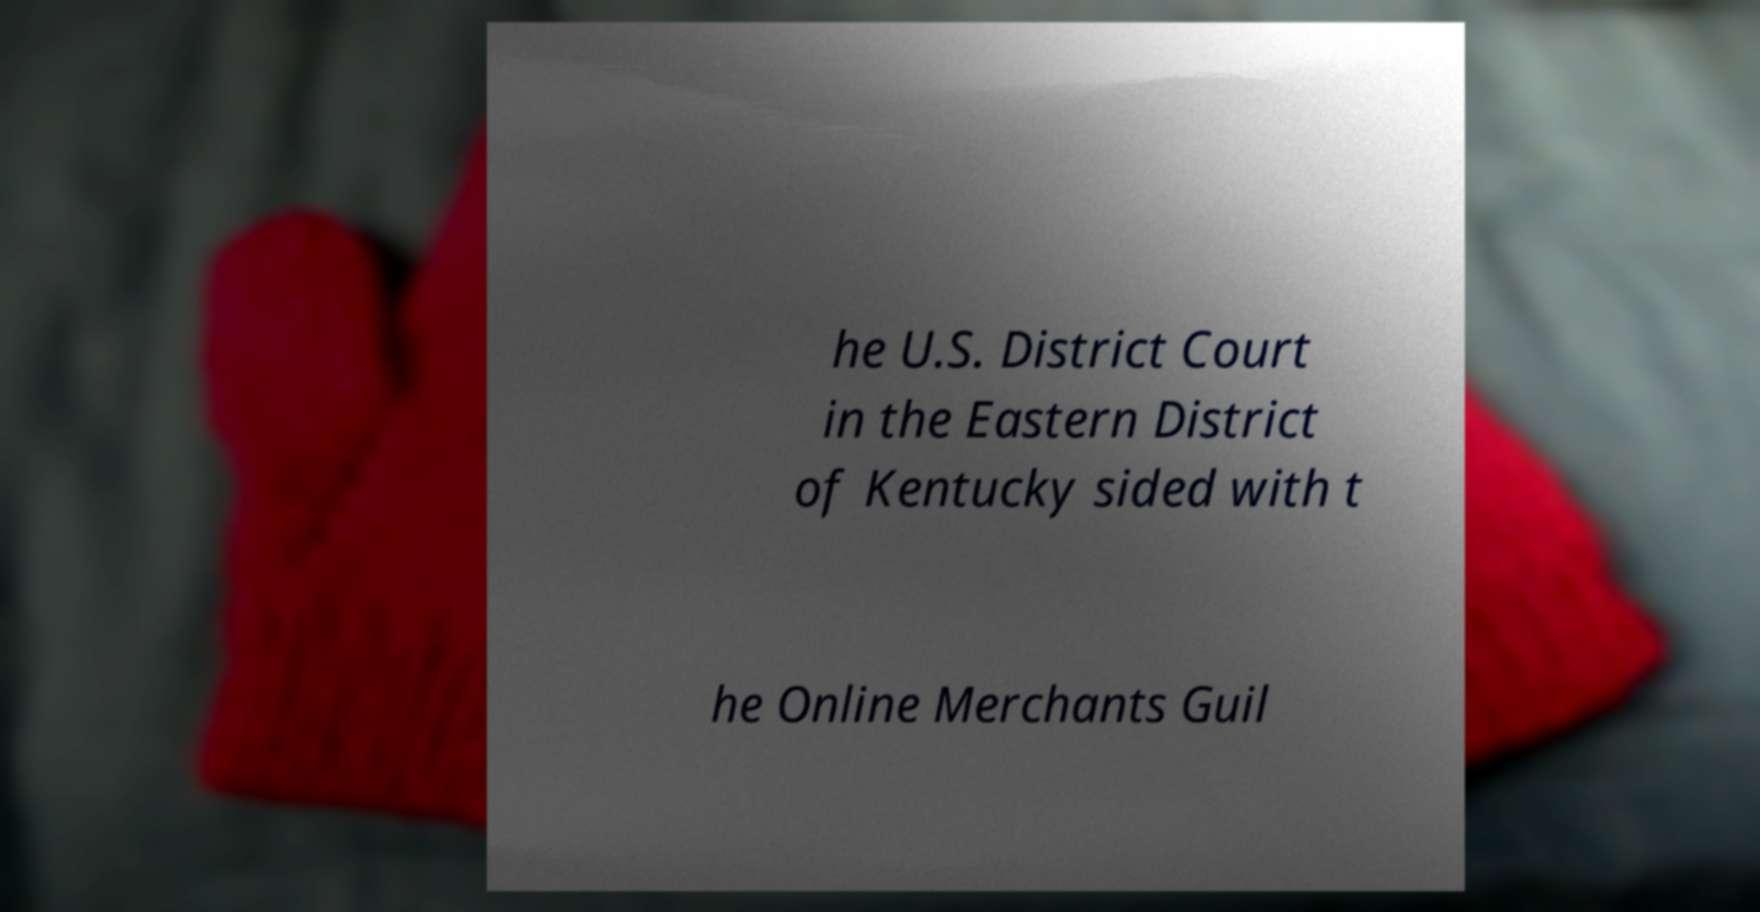There's text embedded in this image that I need extracted. Can you transcribe it verbatim? he U.S. District Court in the Eastern District of Kentucky sided with t he Online Merchants Guil 